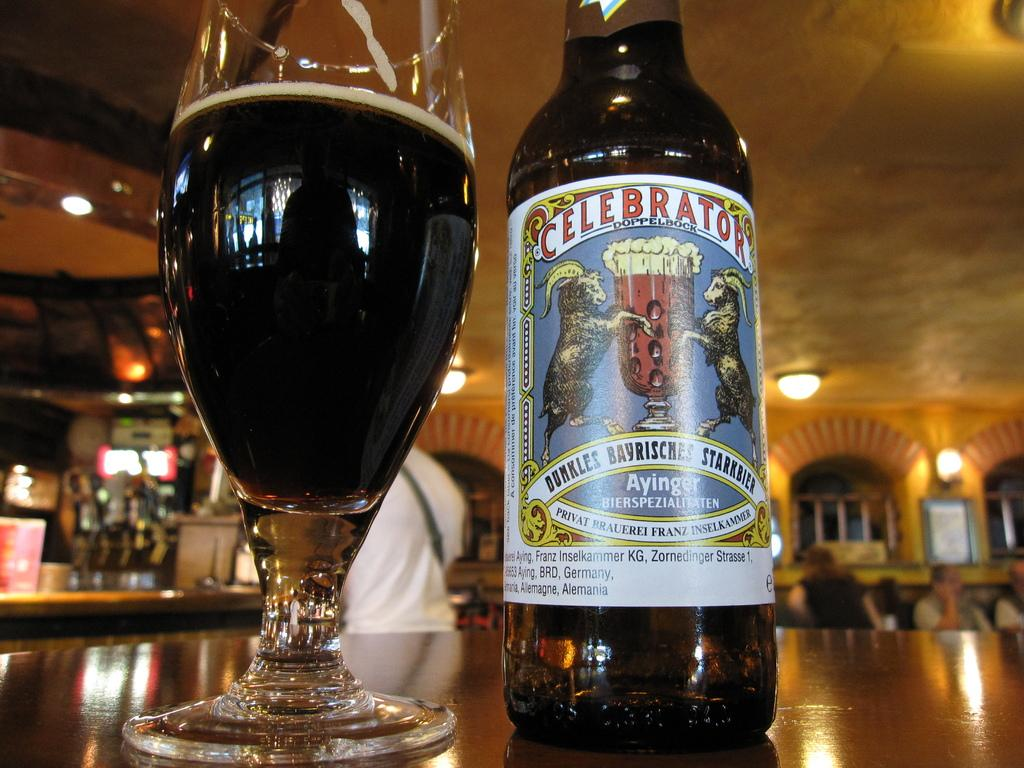<image>
Present a compact description of the photo's key features. Celebrator wine bottle that says: Ayinger, made in Germany. 